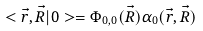Convert formula to latex. <formula><loc_0><loc_0><loc_500><loc_500>< \vec { r } , \vec { R } | 0 > = \Phi _ { 0 , 0 } ( \vec { R } ) \alpha _ { 0 } ( \vec { r } , \vec { R } )</formula> 